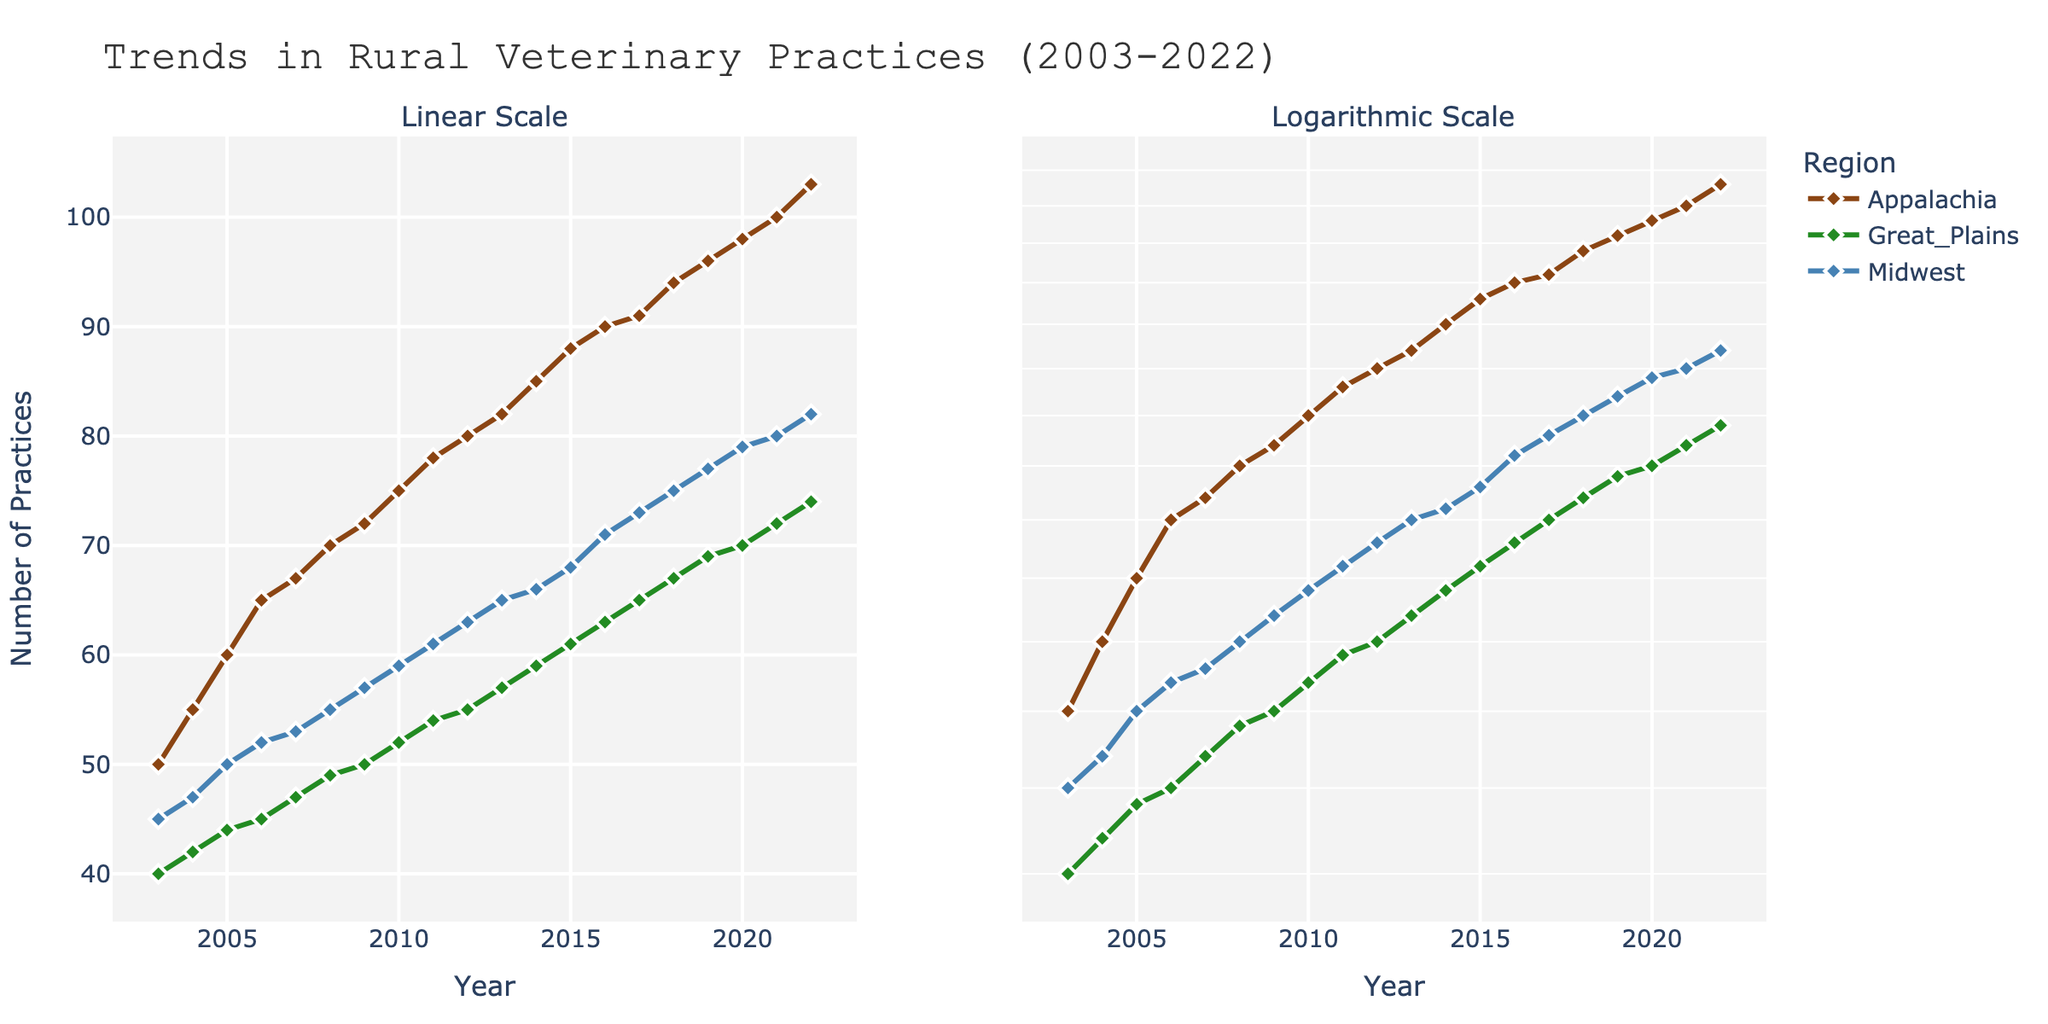What is the title of the plot? The title of the plot is located at the top of the figure, usually larger and more prominent than other text elements. It provides a summary of what the plot is about. By reading it, we know what data or trends are being shown in the figure.
Answer: Trends in Rural Veterinary Practices (2003-2022) Which color represents the Appalachian region in the plot? The color for each region is indicated in the legend, which maps the region names to their respective colors. Looking at the legend, we can identify which color corresponds to each region.
Answer: Brown In which year did the Appalachian region reach 100 practices? To find this, locate the line representing the Appalachian region and follow it until it intersects with the y-axis value of 100. Then, look at the corresponding x-axis value (year).
Answer: 2021 Which region shows the slowest growth in the number of practices over the 20 years? By comparing the slopes of the lines representing each region, we can see which line is the flattest, indicating the slowest rate of growth. The Great Plains region has the smallest increase.
Answer: Great Plains How does the trend of veterinary practices in the Midwest compare to the Appalachian region on the linear scale? By observing both lines on the linear scale subplot, we can compare their shapes and slopes. The Midwest region follows a similar increasing trend as Appalachia but starts from a slightly lower point and remains lower overall.
Answer: Appalachian region has a higher number of practices overall What is the overall trend in the number of veterinary practices in both the Appalachian and Midwest regions? Observing the lines for both regions over time, we can see whether the number of practices increases, decreases, or remains constant. Both regions show an increasing trend in practices.
Answer: Increasing By what factor did the number of practices in the Great Plains increase from 2003 to 2022? On the log scale, we can use the ratio of the final value to the initial value. The Great Plains went from 40 practices in 2003 to 74 in 2022, a factor of 74/40.
Answer: 1.85 How does the rate of increase in the Appalachian region compare to the other regions on the logarithmic scale? On a log scale, an equal growth rate appears as a straight line with a consistent slope. Comparing the slopes of the lines for each region, the Appalachian region has a steeper slope, indicating a faster growth rate.
Answer: Faster Which year shows the most significant increase in the number of practices for the Appalachian region compared to the previous year? By comparing the year-over-year changes, we can identify the year with the steepest increase in the number of practices. The data for changes in values suggests the largest single jump is from 2005 to 2006.
Answer: 2006 